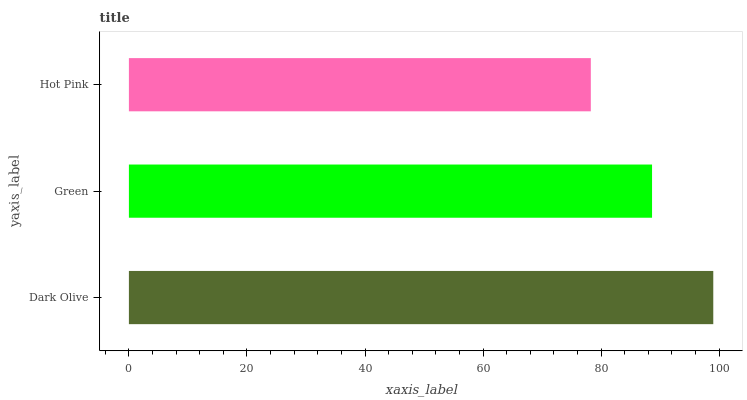Is Hot Pink the minimum?
Answer yes or no. Yes. Is Dark Olive the maximum?
Answer yes or no. Yes. Is Green the minimum?
Answer yes or no. No. Is Green the maximum?
Answer yes or no. No. Is Dark Olive greater than Green?
Answer yes or no. Yes. Is Green less than Dark Olive?
Answer yes or no. Yes. Is Green greater than Dark Olive?
Answer yes or no. No. Is Dark Olive less than Green?
Answer yes or no. No. Is Green the high median?
Answer yes or no. Yes. Is Green the low median?
Answer yes or no. Yes. Is Dark Olive the high median?
Answer yes or no. No. Is Dark Olive the low median?
Answer yes or no. No. 